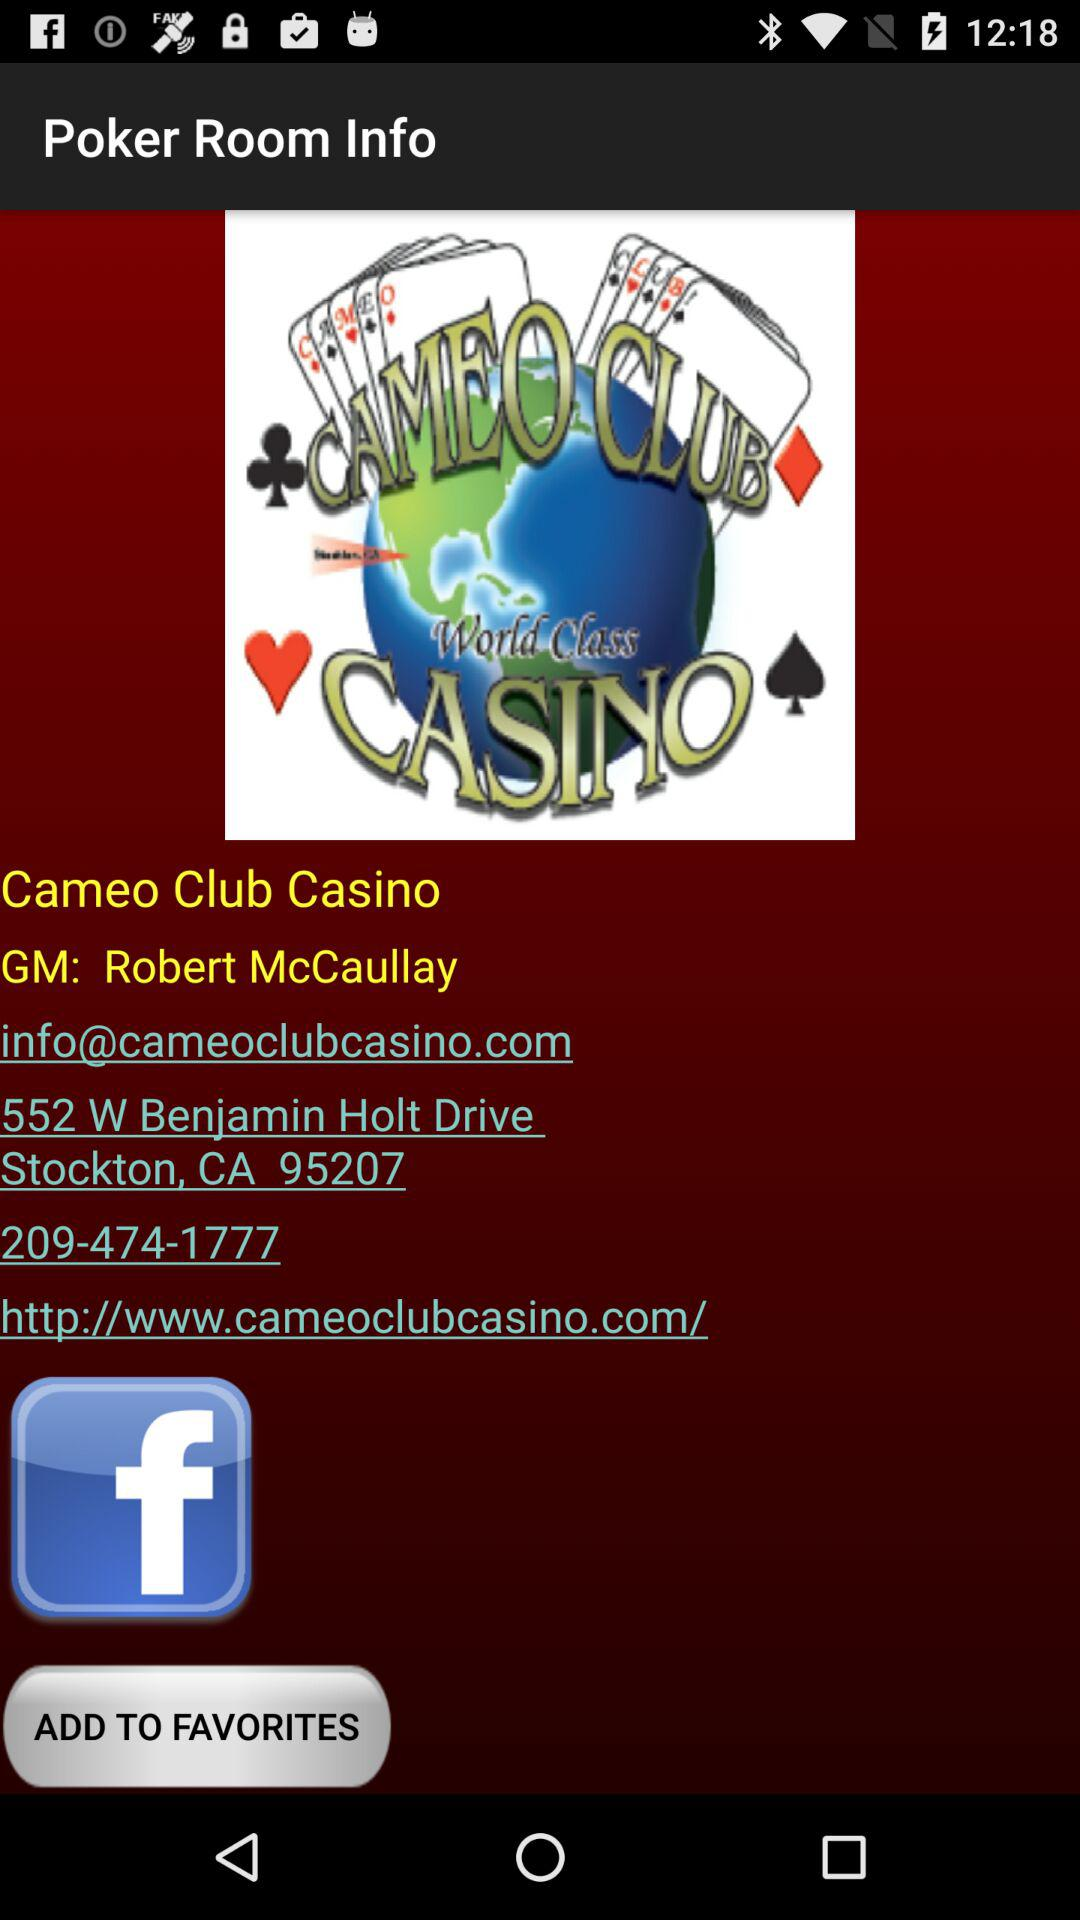What is the name of the application? The name of the application is "Cameo Club Casino". 